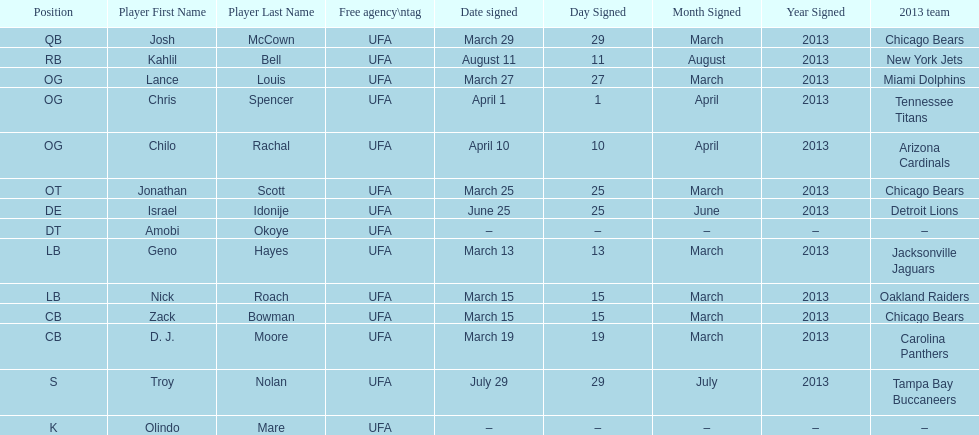His/her first name is the same name as a country. Israel Idonije. 